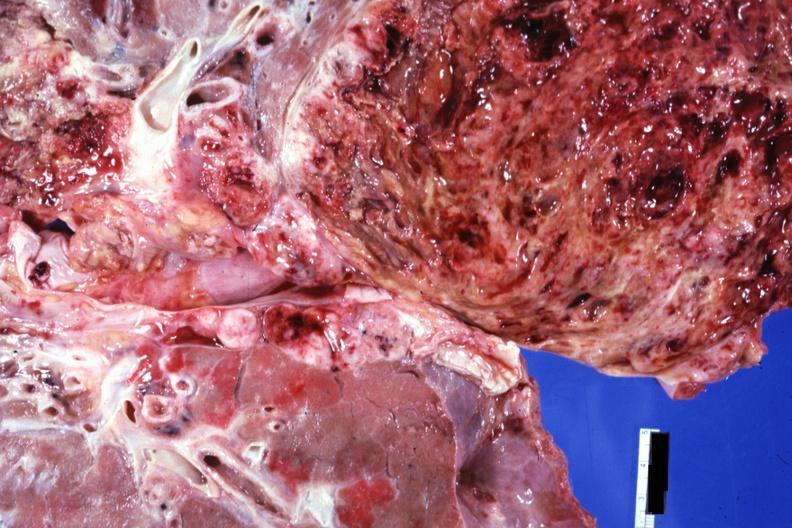s mesentery present?
Answer the question using a single word or phrase. No 